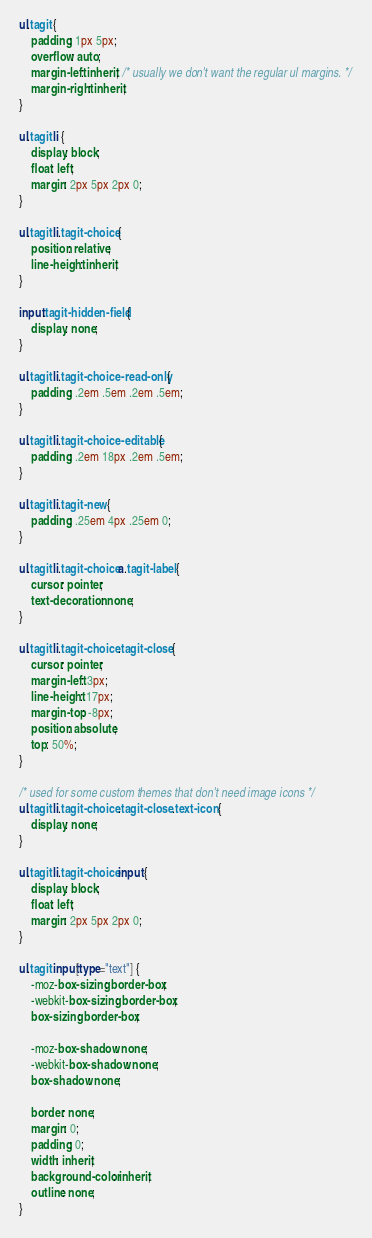<code> <loc_0><loc_0><loc_500><loc_500><_CSS_>ul.tagit {
    padding: 1px 5px;
    overflow: auto;
    margin-left: inherit; /* usually we don't want the regular ul margins. */
    margin-right: inherit;
}

ul.tagit li {
    display: block;
    float: left;
    margin: 2px 5px 2px 0;
}

ul.tagit li.tagit-choice {
    position: relative;
    line-height: inherit;
}

input.tagit-hidden-field {
    display: none;
}

ul.tagit li.tagit-choice-read-only {
    padding: .2em .5em .2em .5em;
}

ul.tagit li.tagit-choice-editable {
    padding: .2em 18px .2em .5em;
}

ul.tagit li.tagit-new {
    padding: .25em 4px .25em 0;
}

ul.tagit li.tagit-choice a.tagit-label {
    cursor: pointer;
    text-decoration: none;
}

ul.tagit li.tagit-choice .tagit-close {
    cursor: pointer;
    margin-left: 3px;
    line-height: 17px;
    margin-top: -8px;
    position: absolute;
    top: 50%;
}

/* used for some custom themes that don't need image icons */
ul.tagit li.tagit-choice .tagit-close .text-icon {
    display: none;
}

ul.tagit li.tagit-choice input {
    display: block;
    float: left;
    margin: 2px 5px 2px 0;
}

ul.tagit input[type="text"] {
    -moz-box-sizing: border-box;
    -webkit-box-sizing: border-box;
    box-sizing: border-box;

    -moz-box-shadow: none;
    -webkit-box-shadow: none;
    box-shadow: none;

    border: none;
    margin: 0;
    padding: 0;
    width: inherit;
    background-color: inherit;
    outline: none;
}
</code> 